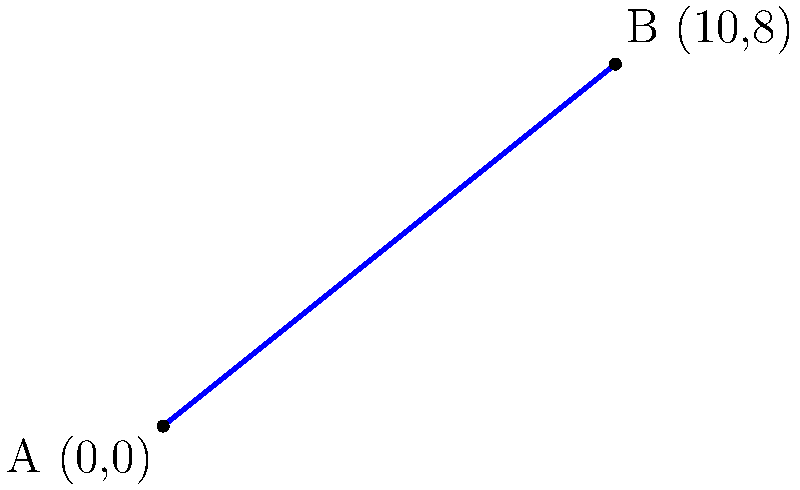At a crime scene, you observe a vehicle's skid marks starting at point A(0,0) and ending at point B(10,8) on a coordinate grid representing the road surface (in meters). Determine the equation of the line representing the vehicle's trajectory based on these skid marks. To find the equation of the line, we'll follow these steps:

1) The general form of a line equation is $y = mx + b$, where $m$ is the slope and $b$ is the y-intercept.

2) Calculate the slope ($m$) using the two points:
   $m = \frac{y_2 - y_1}{x_2 - x_1} = \frac{8 - 0}{10 - 0} = \frac{8}{10} = 0.8$

3) We now have $y = 0.8x + b$

4) To find $b$, we can use either point. Let's use A(0,0):
   $0 = 0.8(0) + b$
   $b = 0$

5) Therefore, the equation of the line is:
   $y = 0.8x$

This equation represents the trajectory of the vehicle based on the skid marks.
Answer: $y = 0.8x$ 